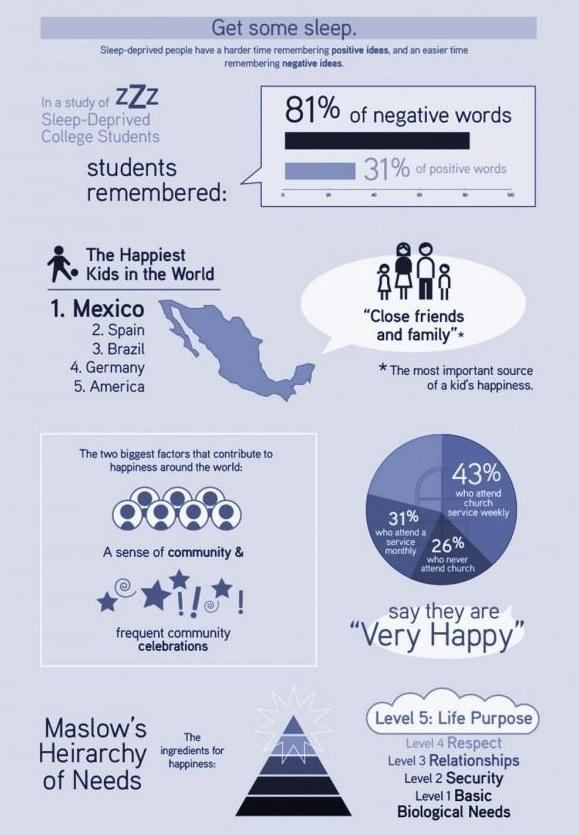Give some essential details in this illustration. In a survey of people who attend services both monthly and weekly, 74% reported that they are very happy. It is my firm belief that for a child, the most important source of happiness is the close friends and family members who provide unconditional love and support. Happiness is a complex and multifaceted concept that is influenced by various factors across the world. According to research, a sense of community and frequent community celebrations have a positive impact on an individual's happiness. 